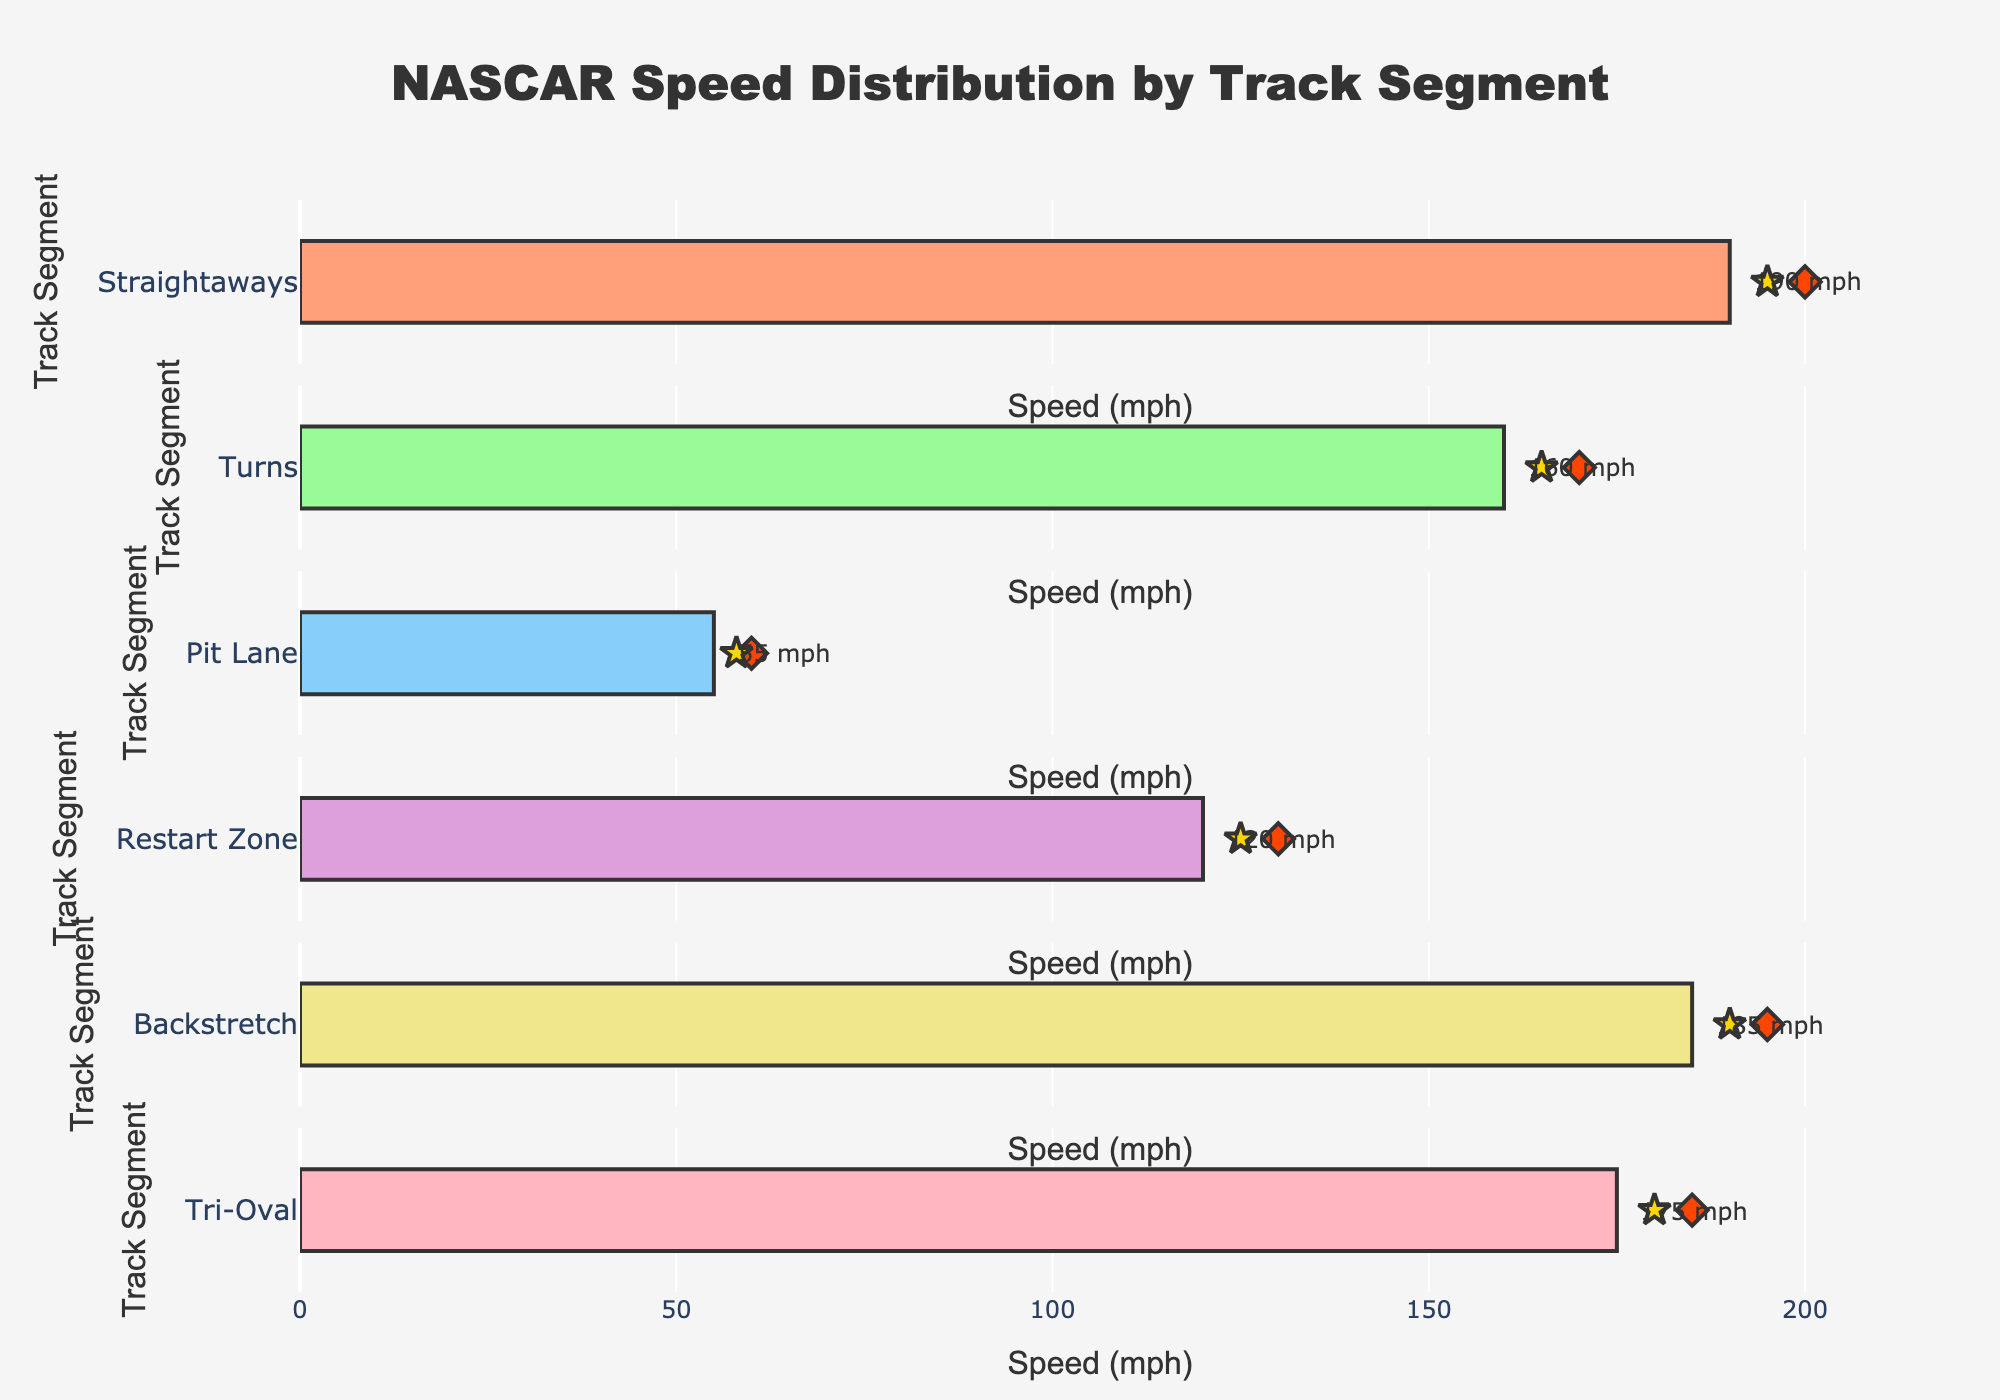What's the title of the figure? The title is usually placed at the top center of the figure. Here it is "NASCAR Speed Distribution by Track Segment".
Answer: NASCAR Speed Distribution by Track Segment What is the average speed for the cars in the Restart Zone? The Restart Zone segment shows a bar representing the average speed with an annotation providing the exact value.
Answer: 120 mph Which track segment has the highest average speed? By inspecting the length of the bars or the annotated values, the Straightaways segment has the highest average speed at 190 mph.
Answer: Straightaways What is the difference between the average speed and the target speed in the Pit Lane segment? The Pit Lane segment has an average speed of 55 mph and a target speed of 58 mph. The difference is calculated as 58 - 55.
Answer: 3 mph How does the average speed in Turns compare to its target speed? The average speed in Turns is 160 mph, and the target speed is 165 mph. We compare these values to see that the average speed is less than the target speed.
Answer: Less than What is the total average speed across all track segments? We sum the average speeds of all segments: 190 + 160 + 55 + 120 + 185 + 175. The sum is 885 mph.
Answer: 885 mph Which track segment has the smallest difference between its average speed and target speed? Calculate the difference between average and target speeds for each segment and find the smallest difference: 
- Straightaways: 195 - 190 = 5 mph
- Turns: 165 - 160 = 5 mph
- Pit Lane: 58 - 55 = 3 mph
- Restart Zone: 125 - 120 = 5 mph
- Backstretch: 190 - 185 = 5 mph
- Tri-Oval: 180 - 175 = 5 mph
The smallest difference is in Pit Lane.
Answer: Pit Lane How many track segments have an average speed over 150 mph? By analyzing the bars and their annotations, we count the segments: Straightaways, Turns, Backstretch, and Tri-Oval all have speeds over 150 mph.
Answer: 4 segments What visual elements represent the benchmark and target speeds, respectively? Benchmark speeds are represented by diamond markers, while target speeds are represented by star markers. This is visible from the shape and color of the markers on the plot.
Answer: Diamond, Star 